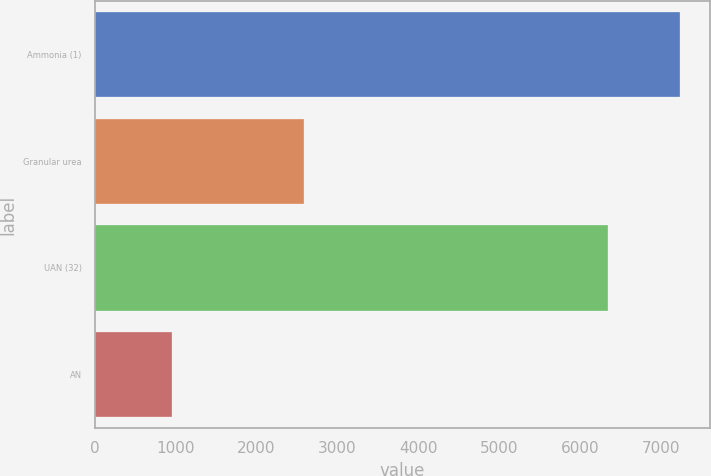Convert chart to OTSL. <chart><loc_0><loc_0><loc_500><loc_500><bar_chart><fcel>Ammonia (1)<fcel>Granular urea<fcel>UAN (32)<fcel>AN<nl><fcel>7244<fcel>2588<fcel>6349<fcel>952<nl></chart> 